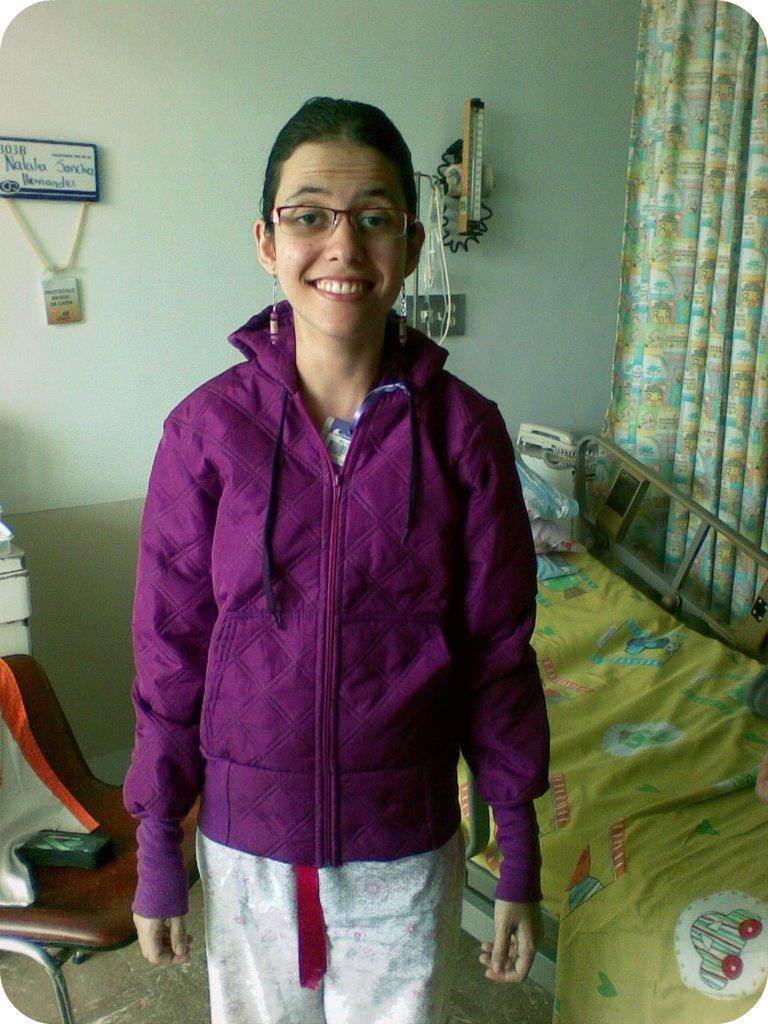What is the main subject of the image? There is a girl standing in the middle of the image. What is the girl wearing? The girl is wearing a purple sweater. What is the girl's facial expression? The girl is smiling. What furniture can be seen on the right side of the image? There is a bed on the right side of the image. What furniture can be seen on the left side of the image? There is a chair on the left side of the image. What is behind the girl in the image? There is a wall behind the girl. How many plants are visible on the bed in the image? There are no plants visible on the bed in the image. 